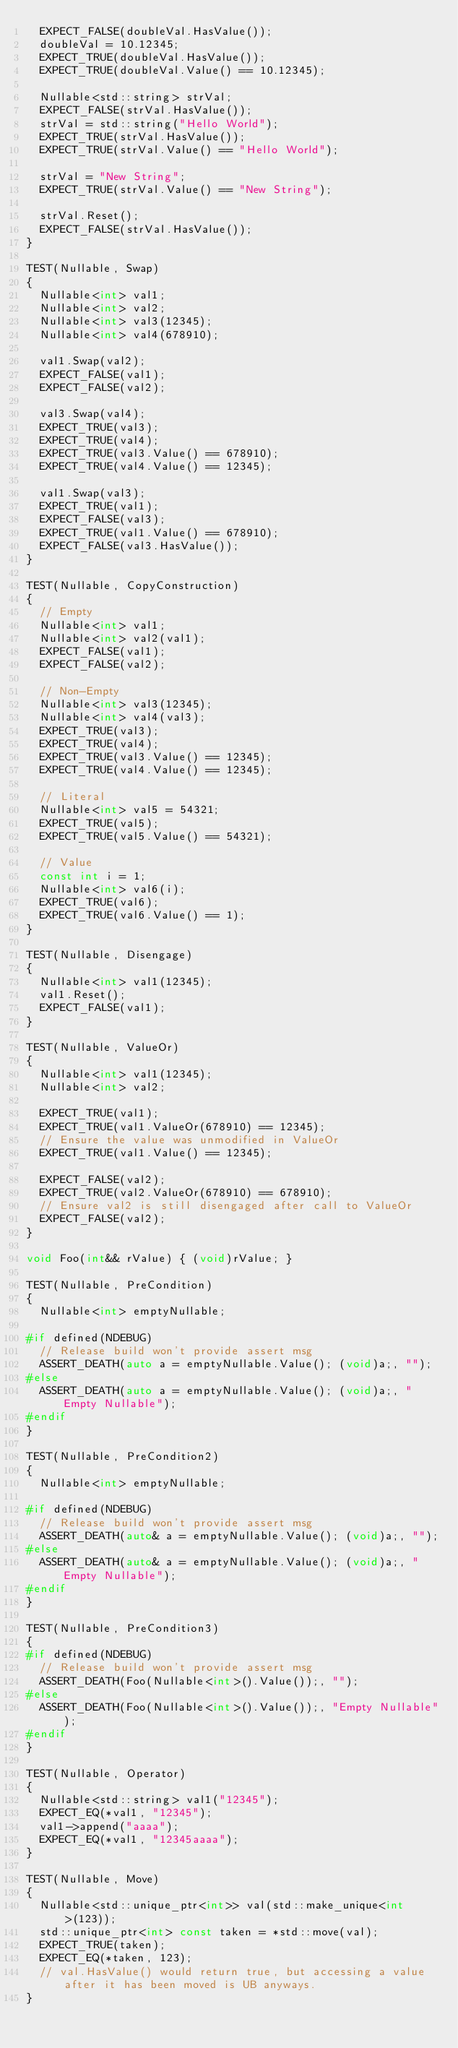Convert code to text. <code><loc_0><loc_0><loc_500><loc_500><_C++_>  EXPECT_FALSE(doubleVal.HasValue());
  doubleVal = 10.12345;
  EXPECT_TRUE(doubleVal.HasValue());
  EXPECT_TRUE(doubleVal.Value() == 10.12345);

  Nullable<std::string> strVal;
  EXPECT_FALSE(strVal.HasValue());
  strVal = std::string("Hello World");
  EXPECT_TRUE(strVal.HasValue());
  EXPECT_TRUE(strVal.Value() == "Hello World");

  strVal = "New String";
  EXPECT_TRUE(strVal.Value() == "New String");

  strVal.Reset();
  EXPECT_FALSE(strVal.HasValue());
}

TEST(Nullable, Swap)
{
  Nullable<int> val1;
  Nullable<int> val2;
  Nullable<int> val3(12345);
  Nullable<int> val4(678910);

  val1.Swap(val2);
  EXPECT_FALSE(val1);
  EXPECT_FALSE(val2);

  val3.Swap(val4);
  EXPECT_TRUE(val3);
  EXPECT_TRUE(val4);
  EXPECT_TRUE(val3.Value() == 678910);
  EXPECT_TRUE(val4.Value() == 12345);

  val1.Swap(val3);
  EXPECT_TRUE(val1);
  EXPECT_FALSE(val3);
  EXPECT_TRUE(val1.Value() == 678910);
  EXPECT_FALSE(val3.HasValue());
}

TEST(Nullable, CopyConstruction)
{
  // Empty
  Nullable<int> val1;
  Nullable<int> val2(val1);
  EXPECT_FALSE(val1);
  EXPECT_FALSE(val2);

  // Non-Empty
  Nullable<int> val3(12345);
  Nullable<int> val4(val3);
  EXPECT_TRUE(val3);
  EXPECT_TRUE(val4);
  EXPECT_TRUE(val3.Value() == 12345);
  EXPECT_TRUE(val4.Value() == 12345);

  // Literal
  Nullable<int> val5 = 54321;
  EXPECT_TRUE(val5);
  EXPECT_TRUE(val5.Value() == 54321);

  // Value
  const int i = 1;
  Nullable<int> val6(i);
  EXPECT_TRUE(val6);
  EXPECT_TRUE(val6.Value() == 1);
}

TEST(Nullable, Disengage)
{
  Nullable<int> val1(12345);
  val1.Reset();
  EXPECT_FALSE(val1);
}

TEST(Nullable, ValueOr)
{
  Nullable<int> val1(12345);
  Nullable<int> val2;

  EXPECT_TRUE(val1);
  EXPECT_TRUE(val1.ValueOr(678910) == 12345);
  // Ensure the value was unmodified in ValueOr
  EXPECT_TRUE(val1.Value() == 12345);

  EXPECT_FALSE(val2);
  EXPECT_TRUE(val2.ValueOr(678910) == 678910);
  // Ensure val2 is still disengaged after call to ValueOr
  EXPECT_FALSE(val2);
}

void Foo(int&& rValue) { (void)rValue; }

TEST(Nullable, PreCondition)
{
  Nullable<int> emptyNullable;

#if defined(NDEBUG)
  // Release build won't provide assert msg
  ASSERT_DEATH(auto a = emptyNullable.Value(); (void)a;, "");
#else
  ASSERT_DEATH(auto a = emptyNullable.Value(); (void)a;, "Empty Nullable");
#endif
}

TEST(Nullable, PreCondition2)
{
  Nullable<int> emptyNullable;

#if defined(NDEBUG)
  // Release build won't provide assert msg
  ASSERT_DEATH(auto& a = emptyNullable.Value(); (void)a;, "");
#else
  ASSERT_DEATH(auto& a = emptyNullable.Value(); (void)a;, "Empty Nullable");
#endif
}

TEST(Nullable, PreCondition3)
{
#if defined(NDEBUG)
  // Release build won't provide assert msg
  ASSERT_DEATH(Foo(Nullable<int>().Value());, "");
#else
  ASSERT_DEATH(Foo(Nullable<int>().Value());, "Empty Nullable");
#endif
}

TEST(Nullable, Operator)
{
  Nullable<std::string> val1("12345");
  EXPECT_EQ(*val1, "12345");
  val1->append("aaaa");
  EXPECT_EQ(*val1, "12345aaaa");
}

TEST(Nullable, Move)
{
  Nullable<std::unique_ptr<int>> val(std::make_unique<int>(123));
  std::unique_ptr<int> const taken = *std::move(val);
  EXPECT_TRUE(taken);
  EXPECT_EQ(*taken, 123);
  // val.HasValue() would return true, but accessing a value after it has been moved is UB anyways.
}
</code> 